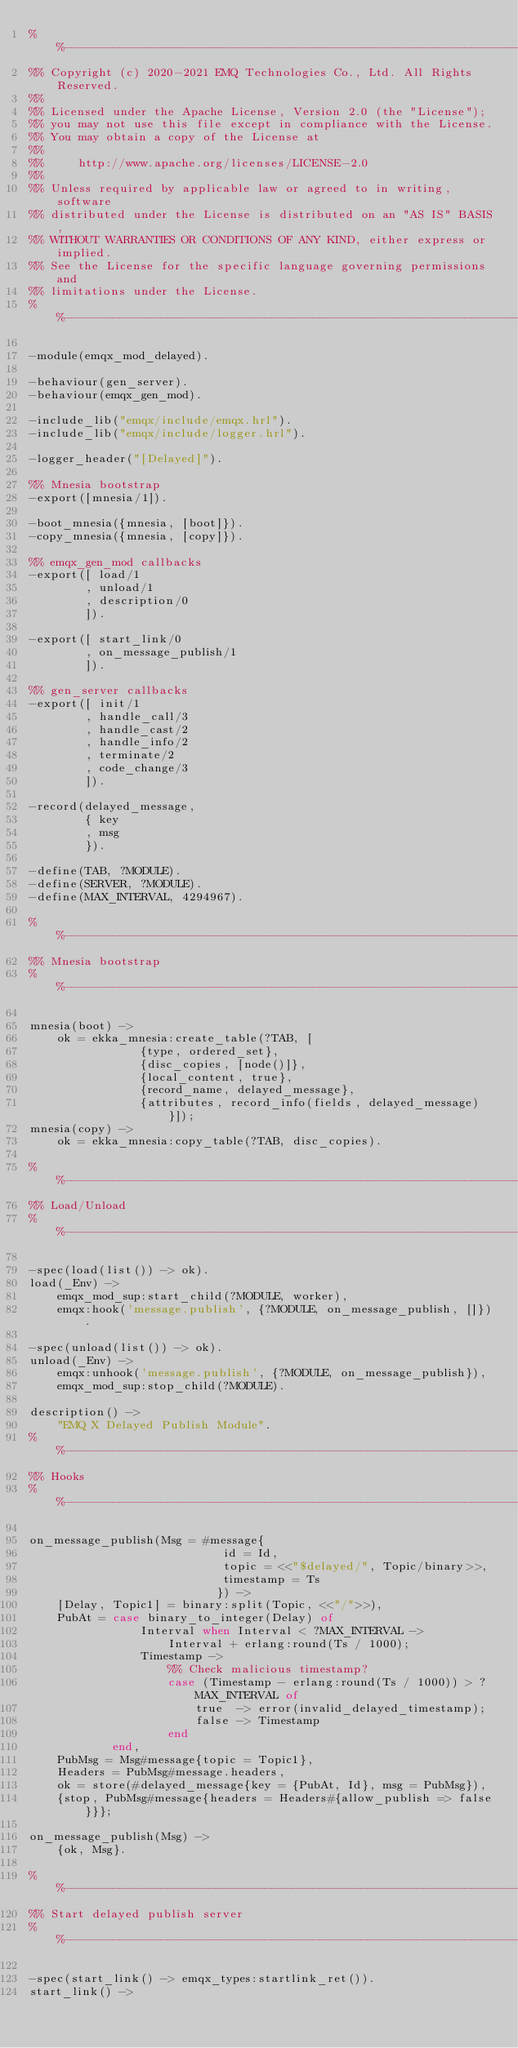Convert code to text. <code><loc_0><loc_0><loc_500><loc_500><_Erlang_>%%--------------------------------------------------------------------
%% Copyright (c) 2020-2021 EMQ Technologies Co., Ltd. All Rights Reserved.
%%
%% Licensed under the Apache License, Version 2.0 (the "License");
%% you may not use this file except in compliance with the License.
%% You may obtain a copy of the License at
%%
%%     http://www.apache.org/licenses/LICENSE-2.0
%%
%% Unless required by applicable law or agreed to in writing, software
%% distributed under the License is distributed on an "AS IS" BASIS,
%% WITHOUT WARRANTIES OR CONDITIONS OF ANY KIND, either express or implied.
%% See the License for the specific language governing permissions and
%% limitations under the License.
%%--------------------------------------------------------------------

-module(emqx_mod_delayed).

-behaviour(gen_server).
-behaviour(emqx_gen_mod).

-include_lib("emqx/include/emqx.hrl").
-include_lib("emqx/include/logger.hrl").

-logger_header("[Delayed]").

%% Mnesia bootstrap
-export([mnesia/1]).

-boot_mnesia({mnesia, [boot]}).
-copy_mnesia({mnesia, [copy]}).

%% emqx_gen_mod callbacks
-export([ load/1
        , unload/1
        , description/0
        ]).

-export([ start_link/0
        , on_message_publish/1
        ]).

%% gen_server callbacks
-export([ init/1
        , handle_call/3
        , handle_cast/2
        , handle_info/2
        , terminate/2
        , code_change/3
        ]).

-record(delayed_message,
        { key
        , msg
        }).

-define(TAB, ?MODULE).
-define(SERVER, ?MODULE).
-define(MAX_INTERVAL, 4294967).

%%--------------------------------------------------------------------
%% Mnesia bootstrap
%%--------------------------------------------------------------------

mnesia(boot) ->
    ok = ekka_mnesia:create_table(?TAB, [
                {type, ordered_set},
                {disc_copies, [node()]},
                {local_content, true},
                {record_name, delayed_message},
                {attributes, record_info(fields, delayed_message)}]);
mnesia(copy) ->
    ok = ekka_mnesia:copy_table(?TAB, disc_copies).

%%--------------------------------------------------------------------
%% Load/Unload
%%--------------------------------------------------------------------

-spec(load(list()) -> ok).
load(_Env) ->
    emqx_mod_sup:start_child(?MODULE, worker),
    emqx:hook('message.publish', {?MODULE, on_message_publish, []}).

-spec(unload(list()) -> ok).
unload(_Env) ->
    emqx:unhook('message.publish', {?MODULE, on_message_publish}),
    emqx_mod_sup:stop_child(?MODULE).

description() ->
    "EMQ X Delayed Publish Module".
%%--------------------------------------------------------------------
%% Hooks
%%--------------------------------------------------------------------

on_message_publish(Msg = #message{
                            id = Id,
                            topic = <<"$delayed/", Topic/binary>>,
                            timestamp = Ts
                           }) ->
    [Delay, Topic1] = binary:split(Topic, <<"/">>),
    PubAt = case binary_to_integer(Delay) of
                Interval when Interval < ?MAX_INTERVAL ->
                    Interval + erlang:round(Ts / 1000);
                Timestamp ->
                    %% Check malicious timestamp?
                    case (Timestamp - erlang:round(Ts / 1000)) > ?MAX_INTERVAL of
                        true  -> error(invalid_delayed_timestamp);
                        false -> Timestamp
                    end
            end,
    PubMsg = Msg#message{topic = Topic1},
    Headers = PubMsg#message.headers,
    ok = store(#delayed_message{key = {PubAt, Id}, msg = PubMsg}),
    {stop, PubMsg#message{headers = Headers#{allow_publish => false}}};

on_message_publish(Msg) ->
    {ok, Msg}.

%%--------------------------------------------------------------------
%% Start delayed publish server
%%--------------------------------------------------------------------

-spec(start_link() -> emqx_types:startlink_ret()).
start_link() -></code> 